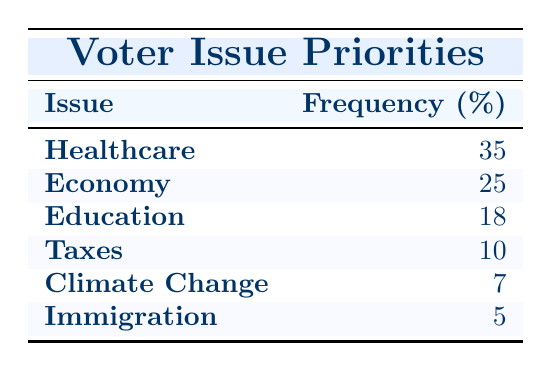What issue has the highest priority among voters? Healthcare has the highest frequency listed in the table at 35.
Answer: Healthcare What is the frequency of voters prioritizing Immigration? The table shows that Immigration has a frequency of 5.
Answer: 5 Which two issues have a combined frequency of at least 50? Summing the frequencies of Healthcare (35) and Economy (25), we get 35 + 25 = 60. These two issues exceed 50.
Answer: Yes Is the frequency of Taxes higher than that of Climate Change? The table indicates that Taxes has a frequency of 10, while Climate Change has 7. Since 10 is greater than 7, the statement is true.
Answer: Yes What is the total frequency for Education, Taxes, and Climate Change? Adding the frequencies for Education (18), Taxes (10), and Climate Change (7) gives us a total of 18 + 10 + 7 = 35.
Answer: 35 Which issue is prioritized more by voters: Education or Immigration? The table shows Education has a frequency of 18 while Immigration has 5. Since 18 is greater than 5, Education is prioritized more.
Answer: Education What is the average frequency of all issues listed? To find the average, sum all frequencies: 35 + 25 + 18 + 10 + 7 + 5 = 100. There are 6 issues, so the average is 100 ÷ 6 ≈ 16.67.
Answer: 16.67 Which issues have a frequency of less than 10? The ones with a frequency below 10 are Climate Change (7) and Immigration (5), as per the table.
Answer: Climate Change, Immigration Is the frequency of Economy greater than the combined frequency of Climate Change and Immigration? Economy has a frequency of 25, while Climate Change has 7 and Immigration has 5. Their combined frequency is 7 + 5 = 12, because 25 is greater than 12, the statement is true.
Answer: Yes 